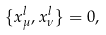Convert formula to latex. <formula><loc_0><loc_0><loc_500><loc_500>\{ x ^ { l } _ { \mu } , x ^ { l } _ { \nu } \} = 0 ,</formula> 